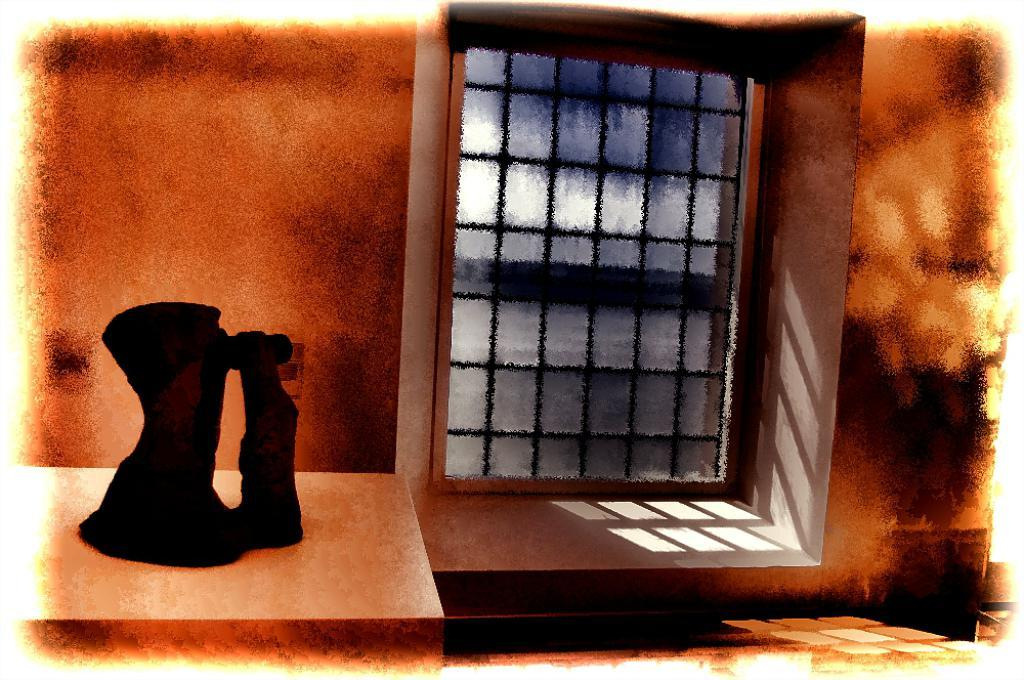What is the main subject on the left side of the image? There is a black object on the left side of the image. What can be seen in the background of the image? There is a wall and a window in the background of the image. How many babies are crawling on the pipe in the image? There is no pipe or babies present in the image. 